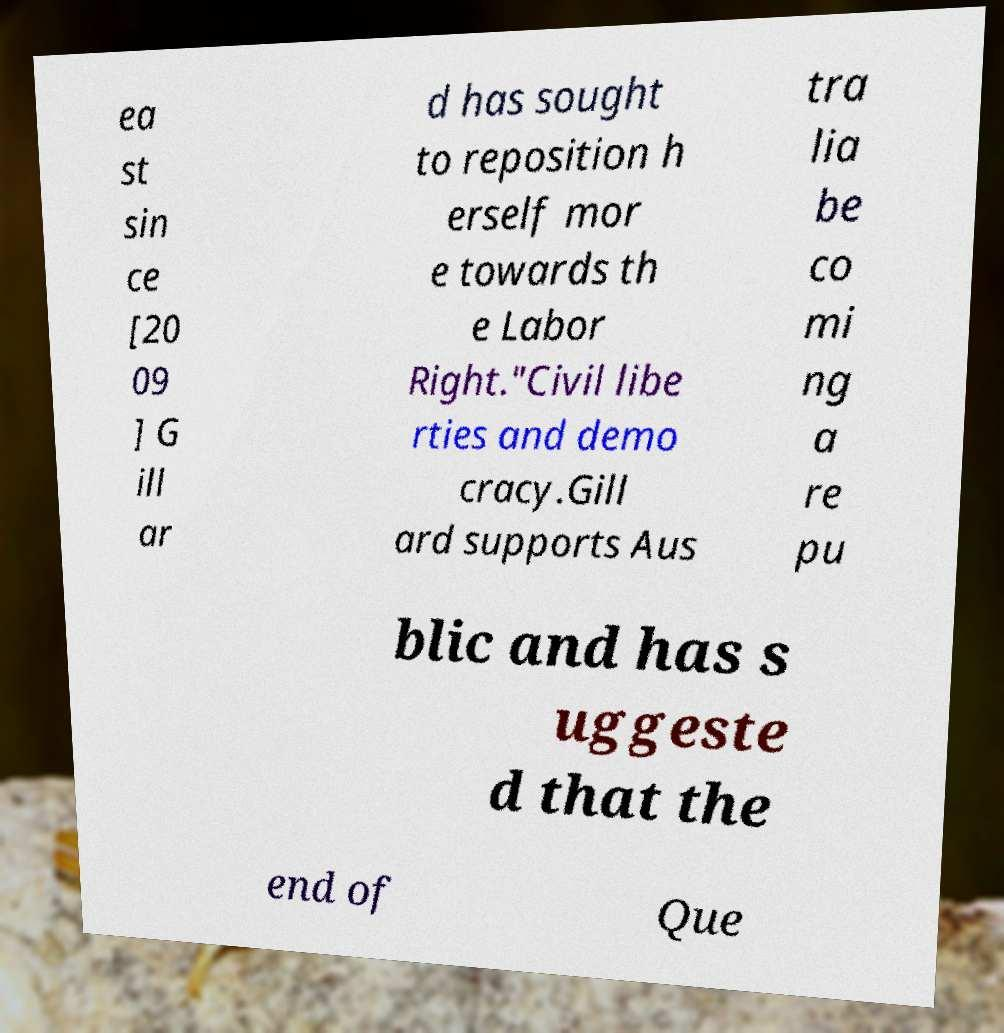There's text embedded in this image that I need extracted. Can you transcribe it verbatim? ea st sin ce [20 09 ] G ill ar d has sought to reposition h erself mor e towards th e Labor Right."Civil libe rties and demo cracy.Gill ard supports Aus tra lia be co mi ng a re pu blic and has s uggeste d that the end of Que 